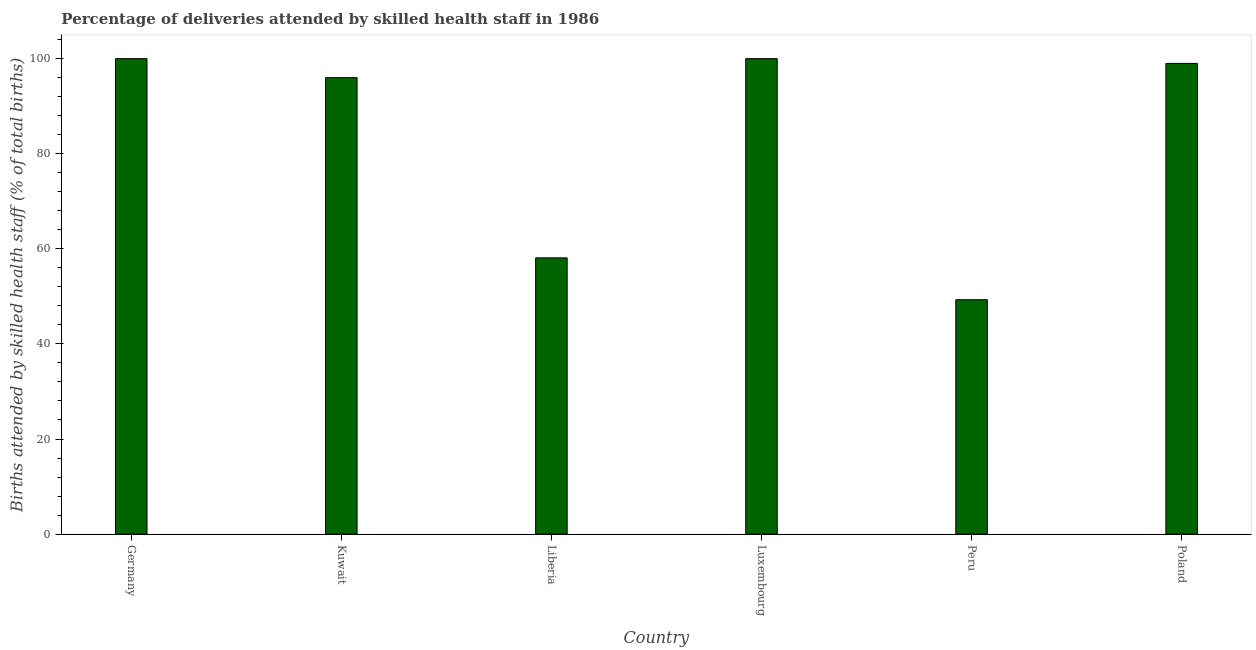Does the graph contain any zero values?
Offer a terse response. No. What is the title of the graph?
Your answer should be compact. Percentage of deliveries attended by skilled health staff in 1986. What is the label or title of the Y-axis?
Keep it short and to the point. Births attended by skilled health staff (% of total births). Across all countries, what is the maximum number of births attended by skilled health staff?
Offer a very short reply. 100. Across all countries, what is the minimum number of births attended by skilled health staff?
Keep it short and to the point. 49.3. What is the sum of the number of births attended by skilled health staff?
Keep it short and to the point. 502.4. What is the difference between the number of births attended by skilled health staff in Liberia and Luxembourg?
Keep it short and to the point. -41.9. What is the average number of births attended by skilled health staff per country?
Give a very brief answer. 83.73. What is the median number of births attended by skilled health staff?
Make the answer very short. 97.5. What is the ratio of the number of births attended by skilled health staff in Kuwait to that in Peru?
Your response must be concise. 1.95. What is the difference between the highest and the second highest number of births attended by skilled health staff?
Your answer should be compact. 0. What is the difference between the highest and the lowest number of births attended by skilled health staff?
Provide a succinct answer. 50.7. Are all the bars in the graph horizontal?
Your answer should be compact. No. How many countries are there in the graph?
Your answer should be very brief. 6. What is the Births attended by skilled health staff (% of total births) of Germany?
Your answer should be compact. 100. What is the Births attended by skilled health staff (% of total births) in Kuwait?
Your response must be concise. 96. What is the Births attended by skilled health staff (% of total births) in Liberia?
Make the answer very short. 58.1. What is the Births attended by skilled health staff (% of total births) in Peru?
Your answer should be compact. 49.3. What is the Births attended by skilled health staff (% of total births) of Poland?
Provide a short and direct response. 99. What is the difference between the Births attended by skilled health staff (% of total births) in Germany and Liberia?
Your answer should be very brief. 41.9. What is the difference between the Births attended by skilled health staff (% of total births) in Germany and Luxembourg?
Your response must be concise. 0. What is the difference between the Births attended by skilled health staff (% of total births) in Germany and Peru?
Offer a very short reply. 50.7. What is the difference between the Births attended by skilled health staff (% of total births) in Kuwait and Liberia?
Your answer should be very brief. 37.9. What is the difference between the Births attended by skilled health staff (% of total births) in Kuwait and Luxembourg?
Your response must be concise. -4. What is the difference between the Births attended by skilled health staff (% of total births) in Kuwait and Peru?
Your answer should be compact. 46.7. What is the difference between the Births attended by skilled health staff (% of total births) in Liberia and Luxembourg?
Give a very brief answer. -41.9. What is the difference between the Births attended by skilled health staff (% of total births) in Liberia and Poland?
Keep it short and to the point. -40.9. What is the difference between the Births attended by skilled health staff (% of total births) in Luxembourg and Peru?
Your answer should be very brief. 50.7. What is the difference between the Births attended by skilled health staff (% of total births) in Peru and Poland?
Offer a very short reply. -49.7. What is the ratio of the Births attended by skilled health staff (% of total births) in Germany to that in Kuwait?
Your answer should be very brief. 1.04. What is the ratio of the Births attended by skilled health staff (% of total births) in Germany to that in Liberia?
Your response must be concise. 1.72. What is the ratio of the Births attended by skilled health staff (% of total births) in Germany to that in Luxembourg?
Your answer should be very brief. 1. What is the ratio of the Births attended by skilled health staff (% of total births) in Germany to that in Peru?
Make the answer very short. 2.03. What is the ratio of the Births attended by skilled health staff (% of total births) in Kuwait to that in Liberia?
Provide a succinct answer. 1.65. What is the ratio of the Births attended by skilled health staff (% of total births) in Kuwait to that in Peru?
Your answer should be compact. 1.95. What is the ratio of the Births attended by skilled health staff (% of total births) in Liberia to that in Luxembourg?
Make the answer very short. 0.58. What is the ratio of the Births attended by skilled health staff (% of total births) in Liberia to that in Peru?
Give a very brief answer. 1.18. What is the ratio of the Births attended by skilled health staff (% of total births) in Liberia to that in Poland?
Ensure brevity in your answer.  0.59. What is the ratio of the Births attended by skilled health staff (% of total births) in Luxembourg to that in Peru?
Keep it short and to the point. 2.03. What is the ratio of the Births attended by skilled health staff (% of total births) in Luxembourg to that in Poland?
Provide a short and direct response. 1.01. What is the ratio of the Births attended by skilled health staff (% of total births) in Peru to that in Poland?
Make the answer very short. 0.5. 